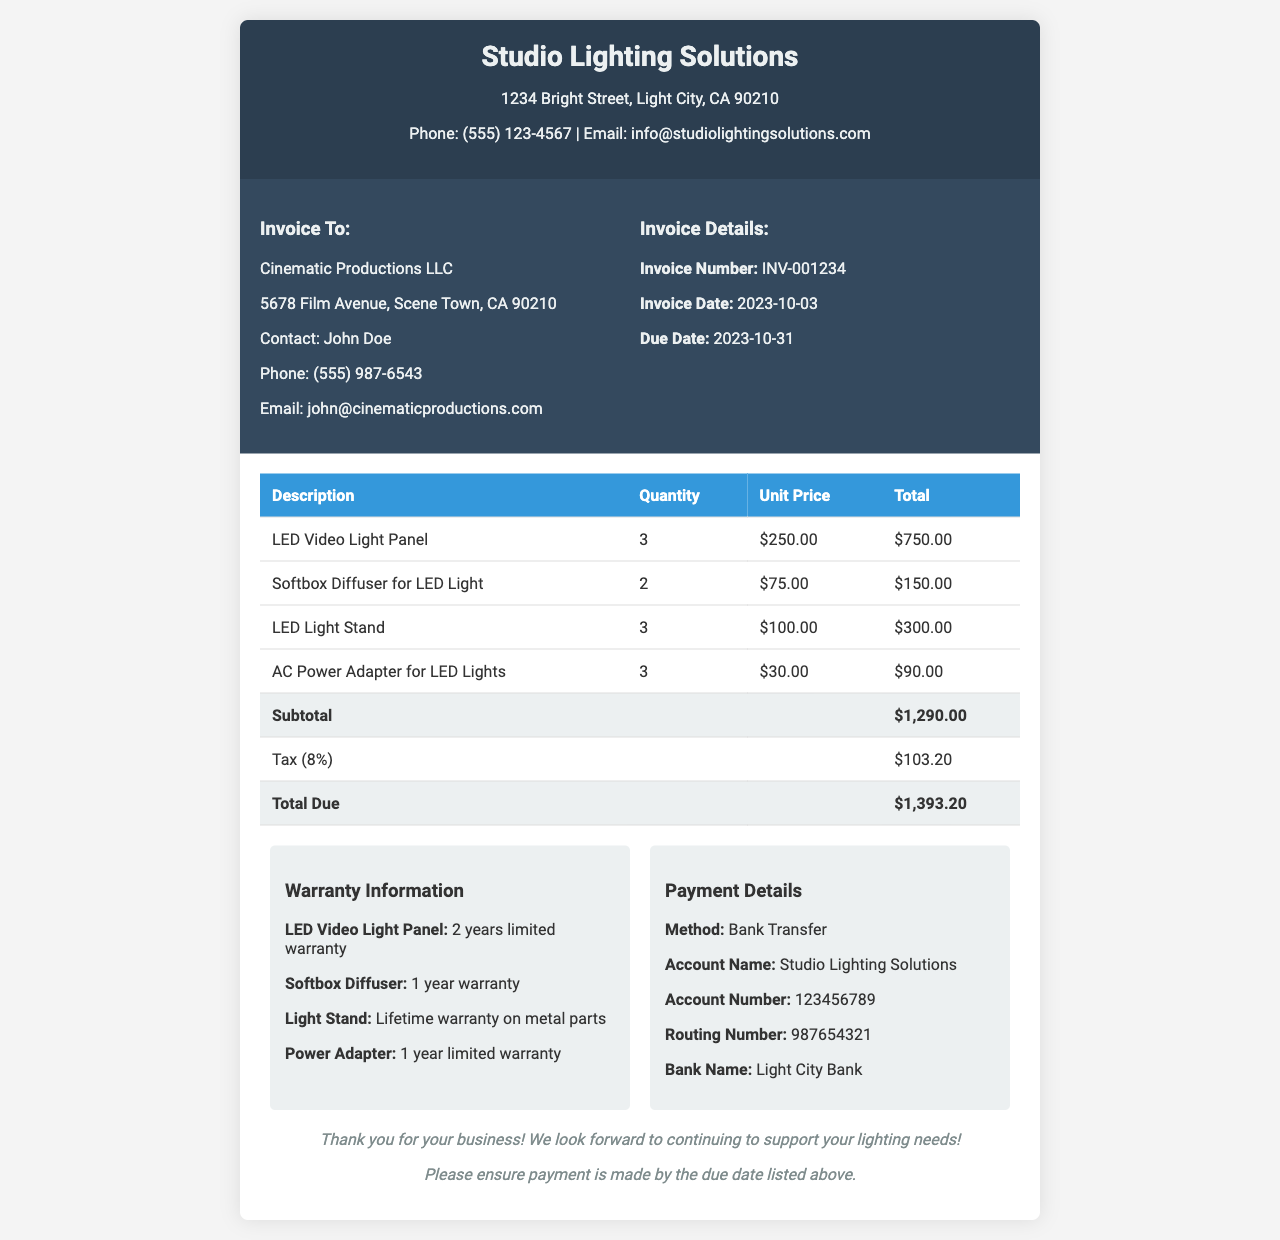What is the invoice number? The invoice number is listed in the document under Invoice Details, identifying it as INV-001234.
Answer: INV-001234 What is the total due amount? The total due is calculated in the document, shown at the bottom after tax is applied, totaling $1,393.20.
Answer: $1,393.20 What is the warranty period for the LED Video Light Panel? The warranty information specifies a 2 years limited warranty for the LED Video Light Panel.
Answer: 2 years limited warranty Who is the invoice addressed to? The document provides the recipient's information, which shows it is for Cinematic Productions LLC.
Answer: Cinematic Productions LLC What is the due date for the payment? The due date is stated clearly in the Invoice Details section of the document as 2023-10-31.
Answer: 2023-10-31 What is the quantity of LED Light Stands purchased? The quantity for the LED Light Stand in the table shows that 3 units were purchased.
Answer: 3 What payment method is specified in the document? The payment details section mentions that the method of payment is Bank Transfer.
Answer: Bank Transfer What is the tax rate applied in the invoice? The tax is calculated as 8% based on the subtotal, which is mentioned in the document.
Answer: 8% 